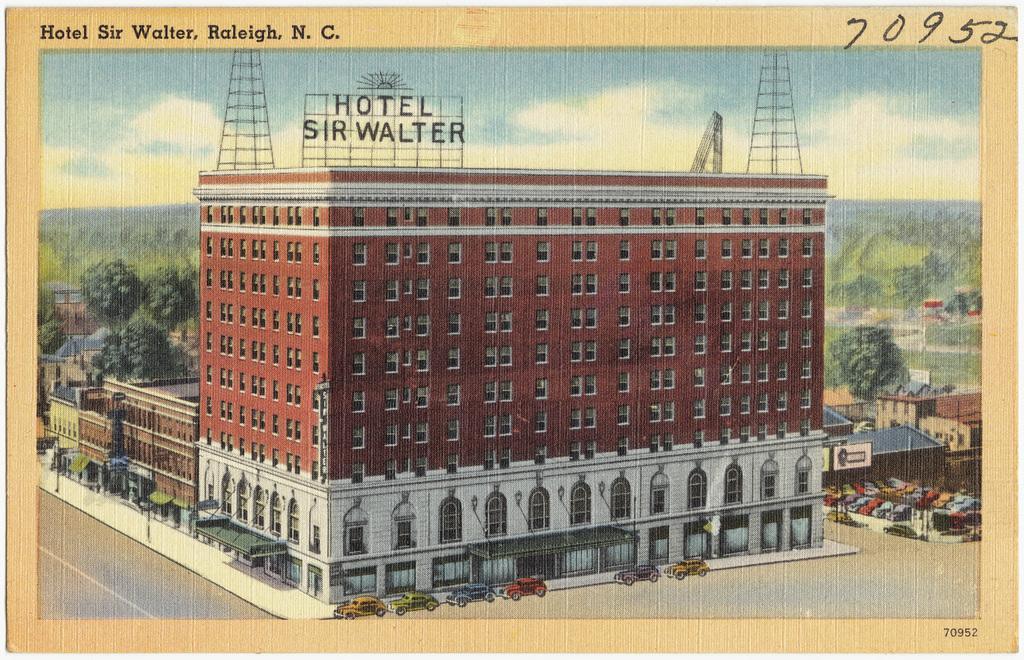How would you summarize this image in a sentence or two? In this image I can see a photograph of the building beside the building there are so many cars also there are some trees and buildings at back. 